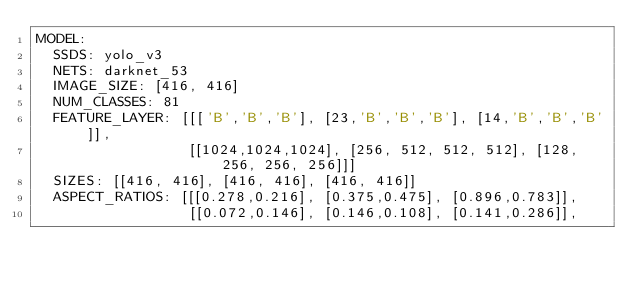<code> <loc_0><loc_0><loc_500><loc_500><_YAML_>MODEL:
  SSDS: yolo_v3
  NETS: darknet_53
  IMAGE_SIZE: [416, 416]
  NUM_CLASSES: 81
  FEATURE_LAYER: [[['B','B','B'], [23,'B','B','B'], [14,'B','B','B']],
                  [[1024,1024,1024], [256, 512, 512, 512], [128, 256, 256, 256]]]
  SIZES: [[416, 416], [416, 416], [416, 416]]
  ASPECT_RATIOS: [[[0.278,0.216], [0.375,0.475], [0.896,0.783]],
                  [[0.072,0.146], [0.146,0.108], [0.141,0.286]],</code> 